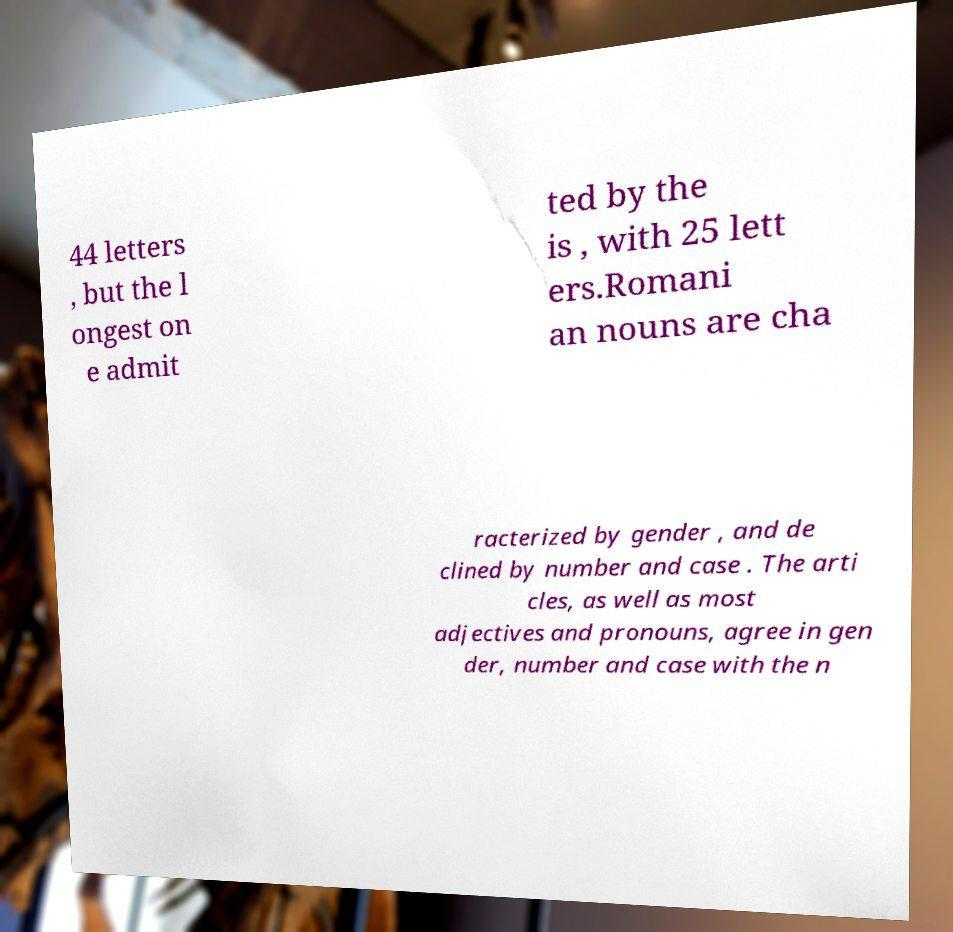I need the written content from this picture converted into text. Can you do that? 44 letters , but the l ongest on e admit ted by the is , with 25 lett ers.Romani an nouns are cha racterized by gender , and de clined by number and case . The arti cles, as well as most adjectives and pronouns, agree in gen der, number and case with the n 